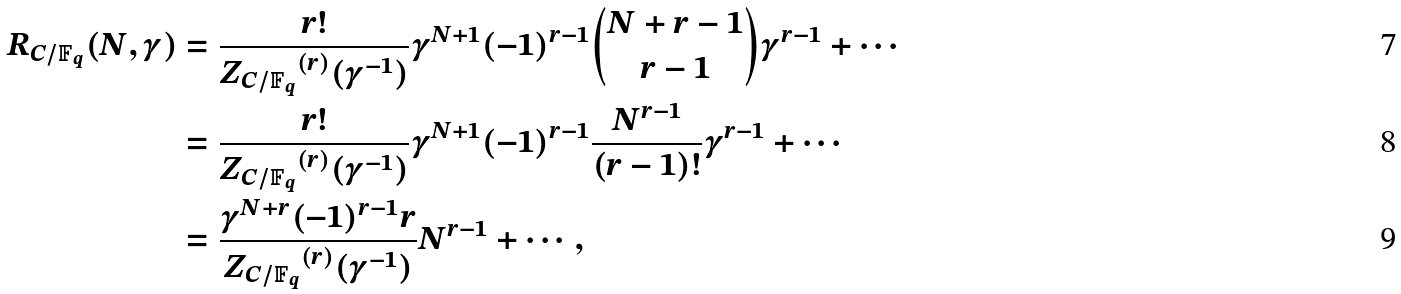Convert formula to latex. <formula><loc_0><loc_0><loc_500><loc_500>R _ { C / \mathbb { F } _ { q } } ( N , \gamma ) & = \frac { r ! } { { Z _ { C / \mathbb { F } _ { q } } } ^ { ( r ) } ( \gamma ^ { - 1 } ) } \gamma ^ { N + 1 } ( - 1 ) ^ { r - 1 } \binom { N + r - 1 } { r - 1 } \gamma ^ { r - 1 } + \cdots \\ & = \frac { r ! } { { Z _ { C / \mathbb { F } _ { q } } } ^ { ( r ) } ( \gamma ^ { - 1 } ) } \gamma ^ { N + 1 } ( - 1 ) ^ { r - 1 } \frac { N ^ { r - 1 } } { ( r - 1 ) ! } \gamma ^ { r - 1 } + \cdots \\ & = \frac { \gamma ^ { N + r } ( - 1 ) ^ { r - 1 } r } { { Z _ { C / \mathbb { F } _ { q } } } ^ { ( r ) } ( \gamma ^ { - 1 } ) } N ^ { r - 1 } + \cdots ,</formula> 